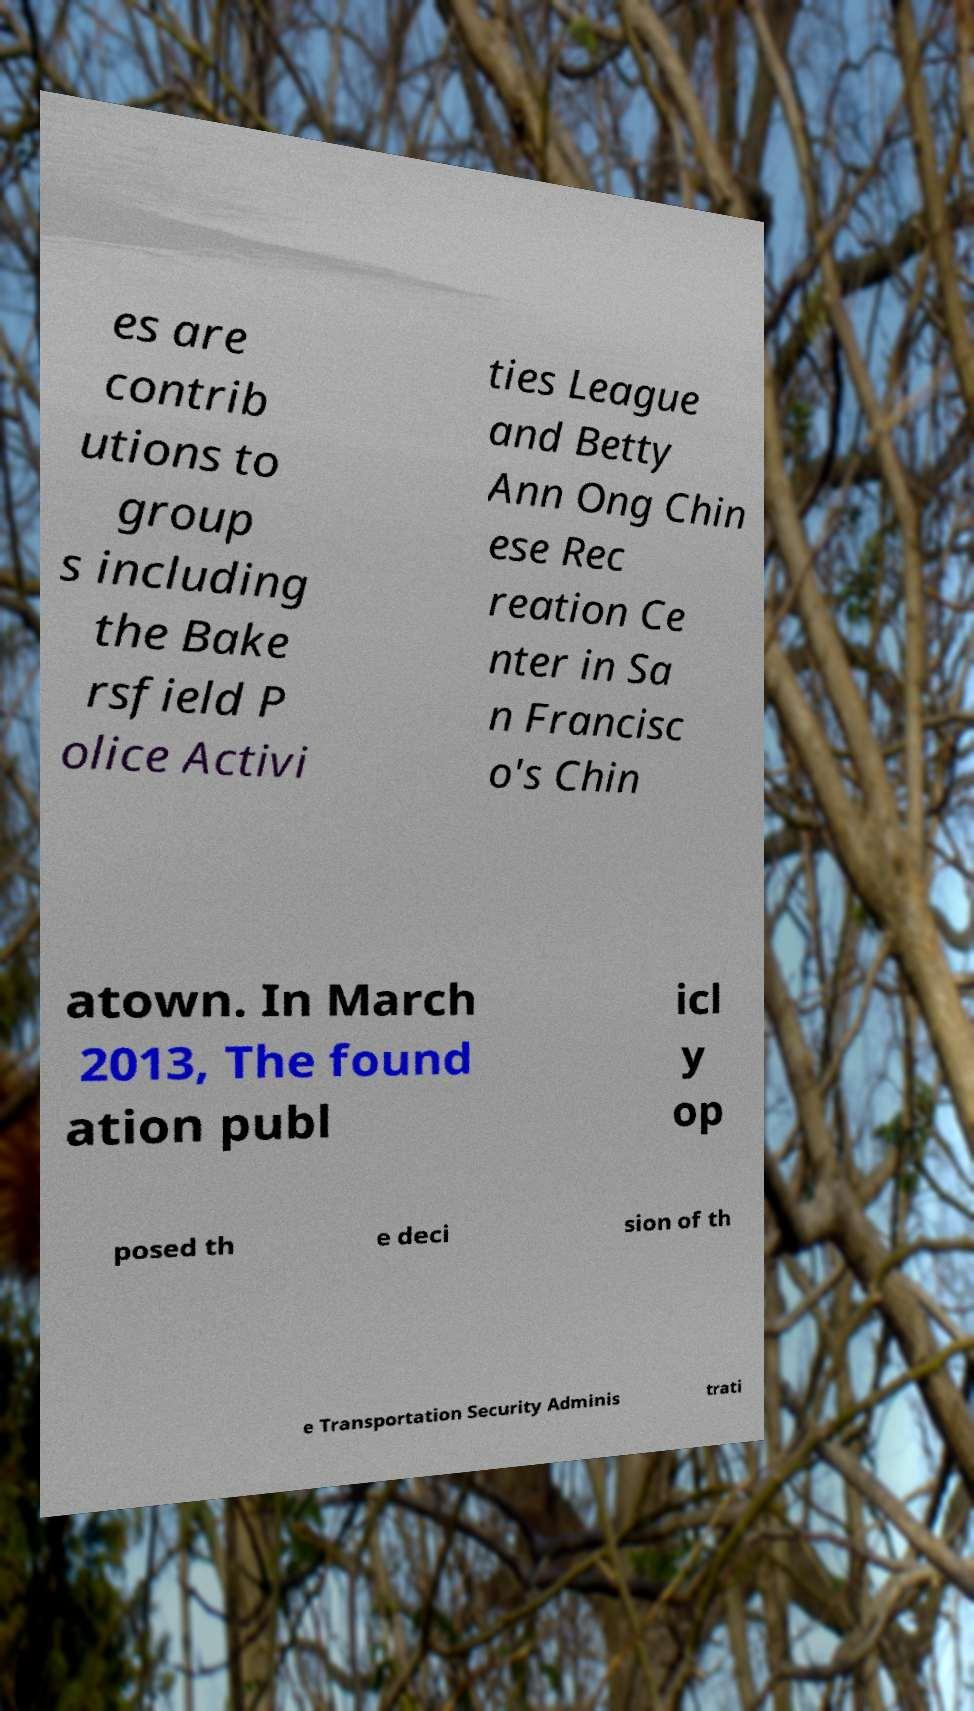Can you read and provide the text displayed in the image?This photo seems to have some interesting text. Can you extract and type it out for me? es are contrib utions to group s including the Bake rsfield P olice Activi ties League and Betty Ann Ong Chin ese Rec reation Ce nter in Sa n Francisc o's Chin atown. In March 2013, The found ation publ icl y op posed th e deci sion of th e Transportation Security Adminis trati 